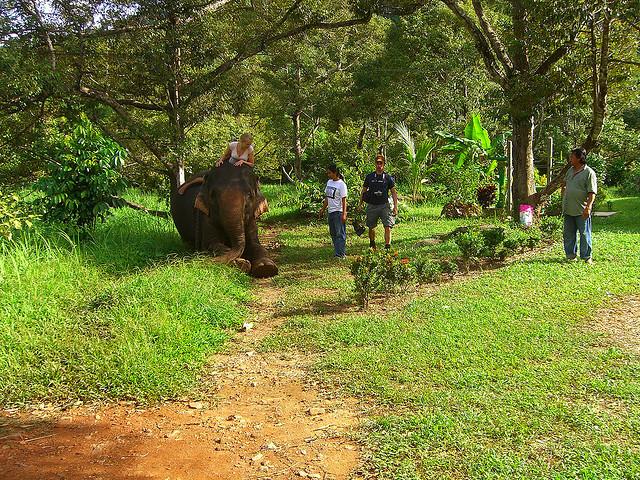Why is the elephant laying down?
Quick response, please. Resting. How many people are in the photo?
Give a very brief answer. 4. Where is the fallen branch?
Write a very short answer. On ground. Is the elephant trained?
Give a very brief answer. Yes. 